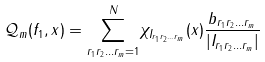<formula> <loc_0><loc_0><loc_500><loc_500>\mathcal { Q } _ { m } ( f _ { 1 } , x ) = \underset { { r _ { 1 } } { r _ { 2 } } \dots { r _ { m } } = 1 } { \overset { N } \sum } \chi _ { I _ { { r _ { 1 } } { r _ { 2 } } \dots { r _ { m } } } } ( x ) \frac { b _ { { r _ { 1 } } { r _ { 2 } } \dots { r _ { m } } } } { | I _ { { r _ { 1 } } { r _ { 2 } } \dots { r _ { m } } } | }</formula> 